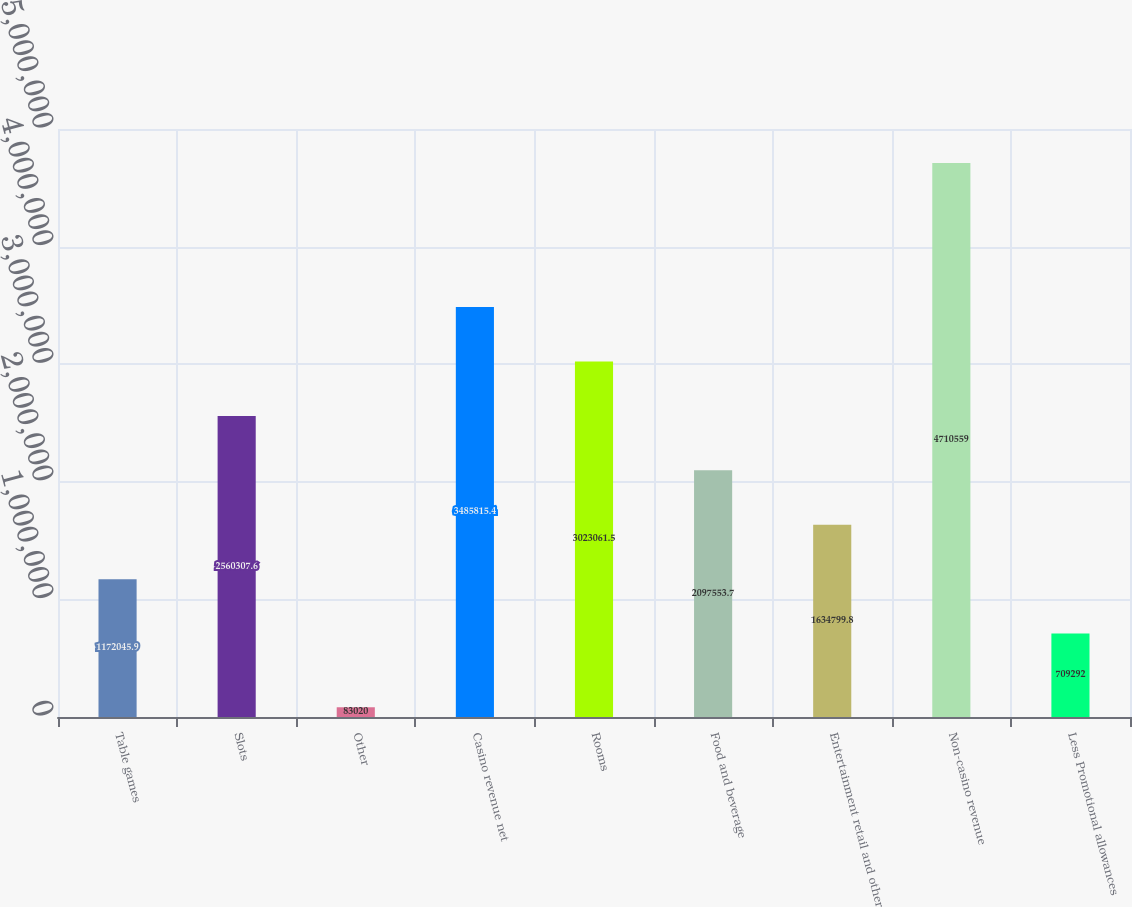<chart> <loc_0><loc_0><loc_500><loc_500><bar_chart><fcel>Table games<fcel>Slots<fcel>Other<fcel>Casino revenue net<fcel>Rooms<fcel>Food and beverage<fcel>Entertainment retail and other<fcel>Non-casino revenue<fcel>Less Promotional allowances<nl><fcel>1.17205e+06<fcel>2.56031e+06<fcel>83020<fcel>3.48582e+06<fcel>3.02306e+06<fcel>2.09755e+06<fcel>1.6348e+06<fcel>4.71056e+06<fcel>709292<nl></chart> 